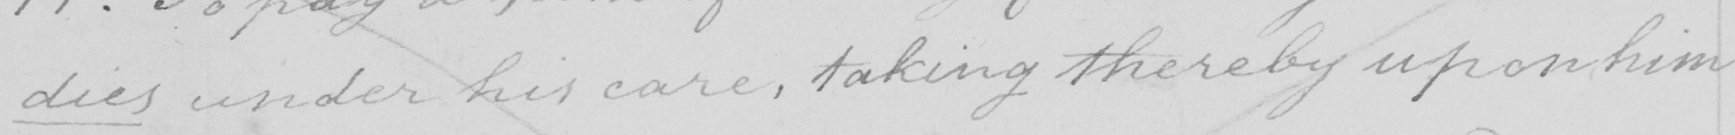What text is written in this handwritten line? dies under his care , taking thereby upon him 